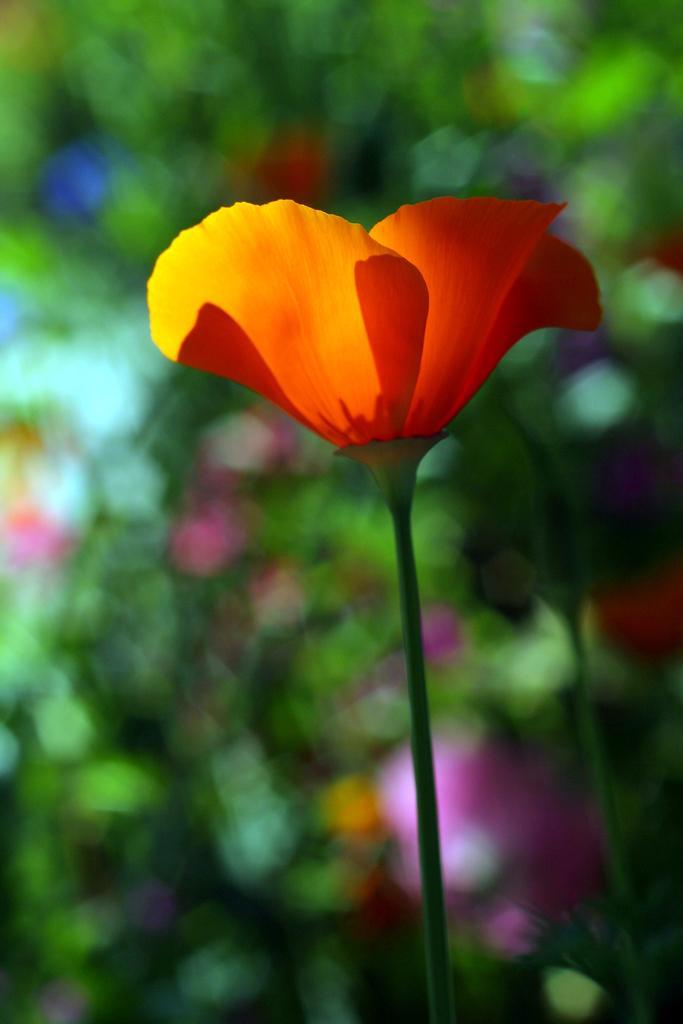In one or two sentences, can you explain what this image depicts? In this image I can see an orange color flower to the plant. In the background I can see the pink, blue, yellow and red color flowers to the plants. But the background is blurry. 